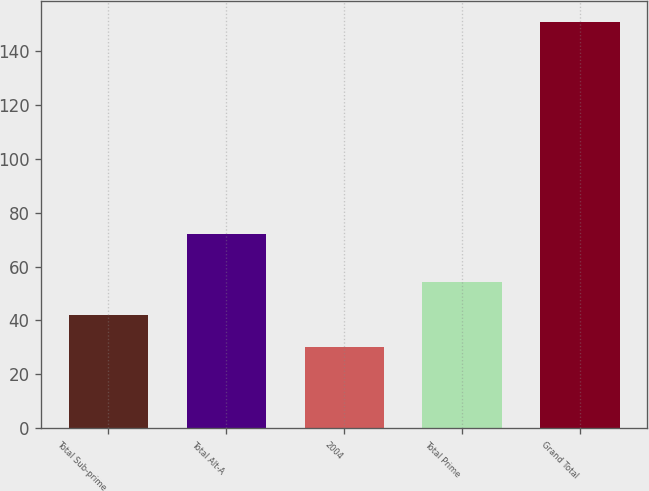<chart> <loc_0><loc_0><loc_500><loc_500><bar_chart><fcel>Total Sub-prime<fcel>Total Alt-A<fcel>2004<fcel>Total Prime<fcel>Grand Total<nl><fcel>42.1<fcel>72<fcel>30<fcel>54.2<fcel>151<nl></chart> 